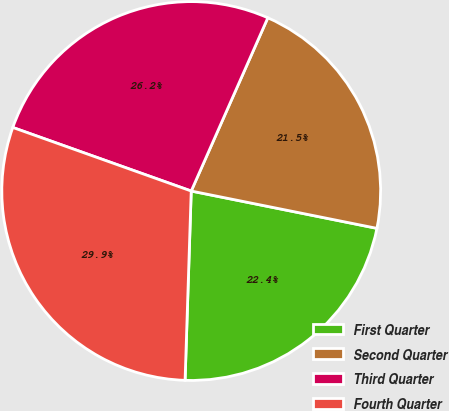Convert chart to OTSL. <chart><loc_0><loc_0><loc_500><loc_500><pie_chart><fcel>First Quarter<fcel>Second Quarter<fcel>Third Quarter<fcel>Fourth Quarter<nl><fcel>22.36%<fcel>21.53%<fcel>26.18%<fcel>29.93%<nl></chart> 